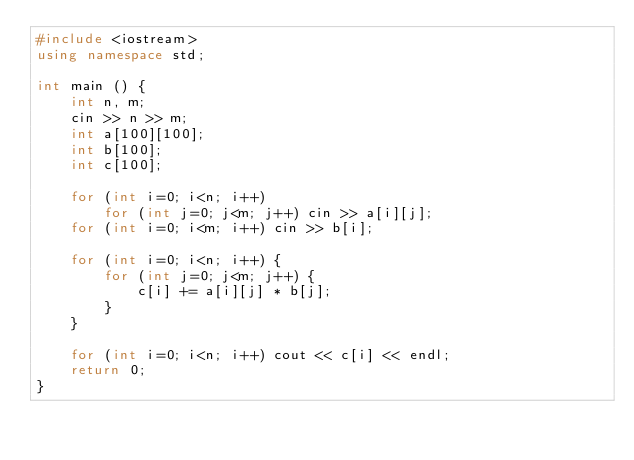<code> <loc_0><loc_0><loc_500><loc_500><_C++_>#include <iostream>
using namespace std;

int main () {
    int n, m;
    cin >> n >> m;
    int a[100][100];
    int b[100];
    int c[100];

    for (int i=0; i<n; i++)
        for (int j=0; j<m; j++) cin >> a[i][j];
    for (int i=0; i<m; i++) cin >> b[i];

    for (int i=0; i<n; i++) {
        for (int j=0; j<m; j++) {
            c[i] += a[i][j] * b[j];
        }
    }

    for (int i=0; i<n; i++) cout << c[i] << endl;
    return 0;
}</code> 